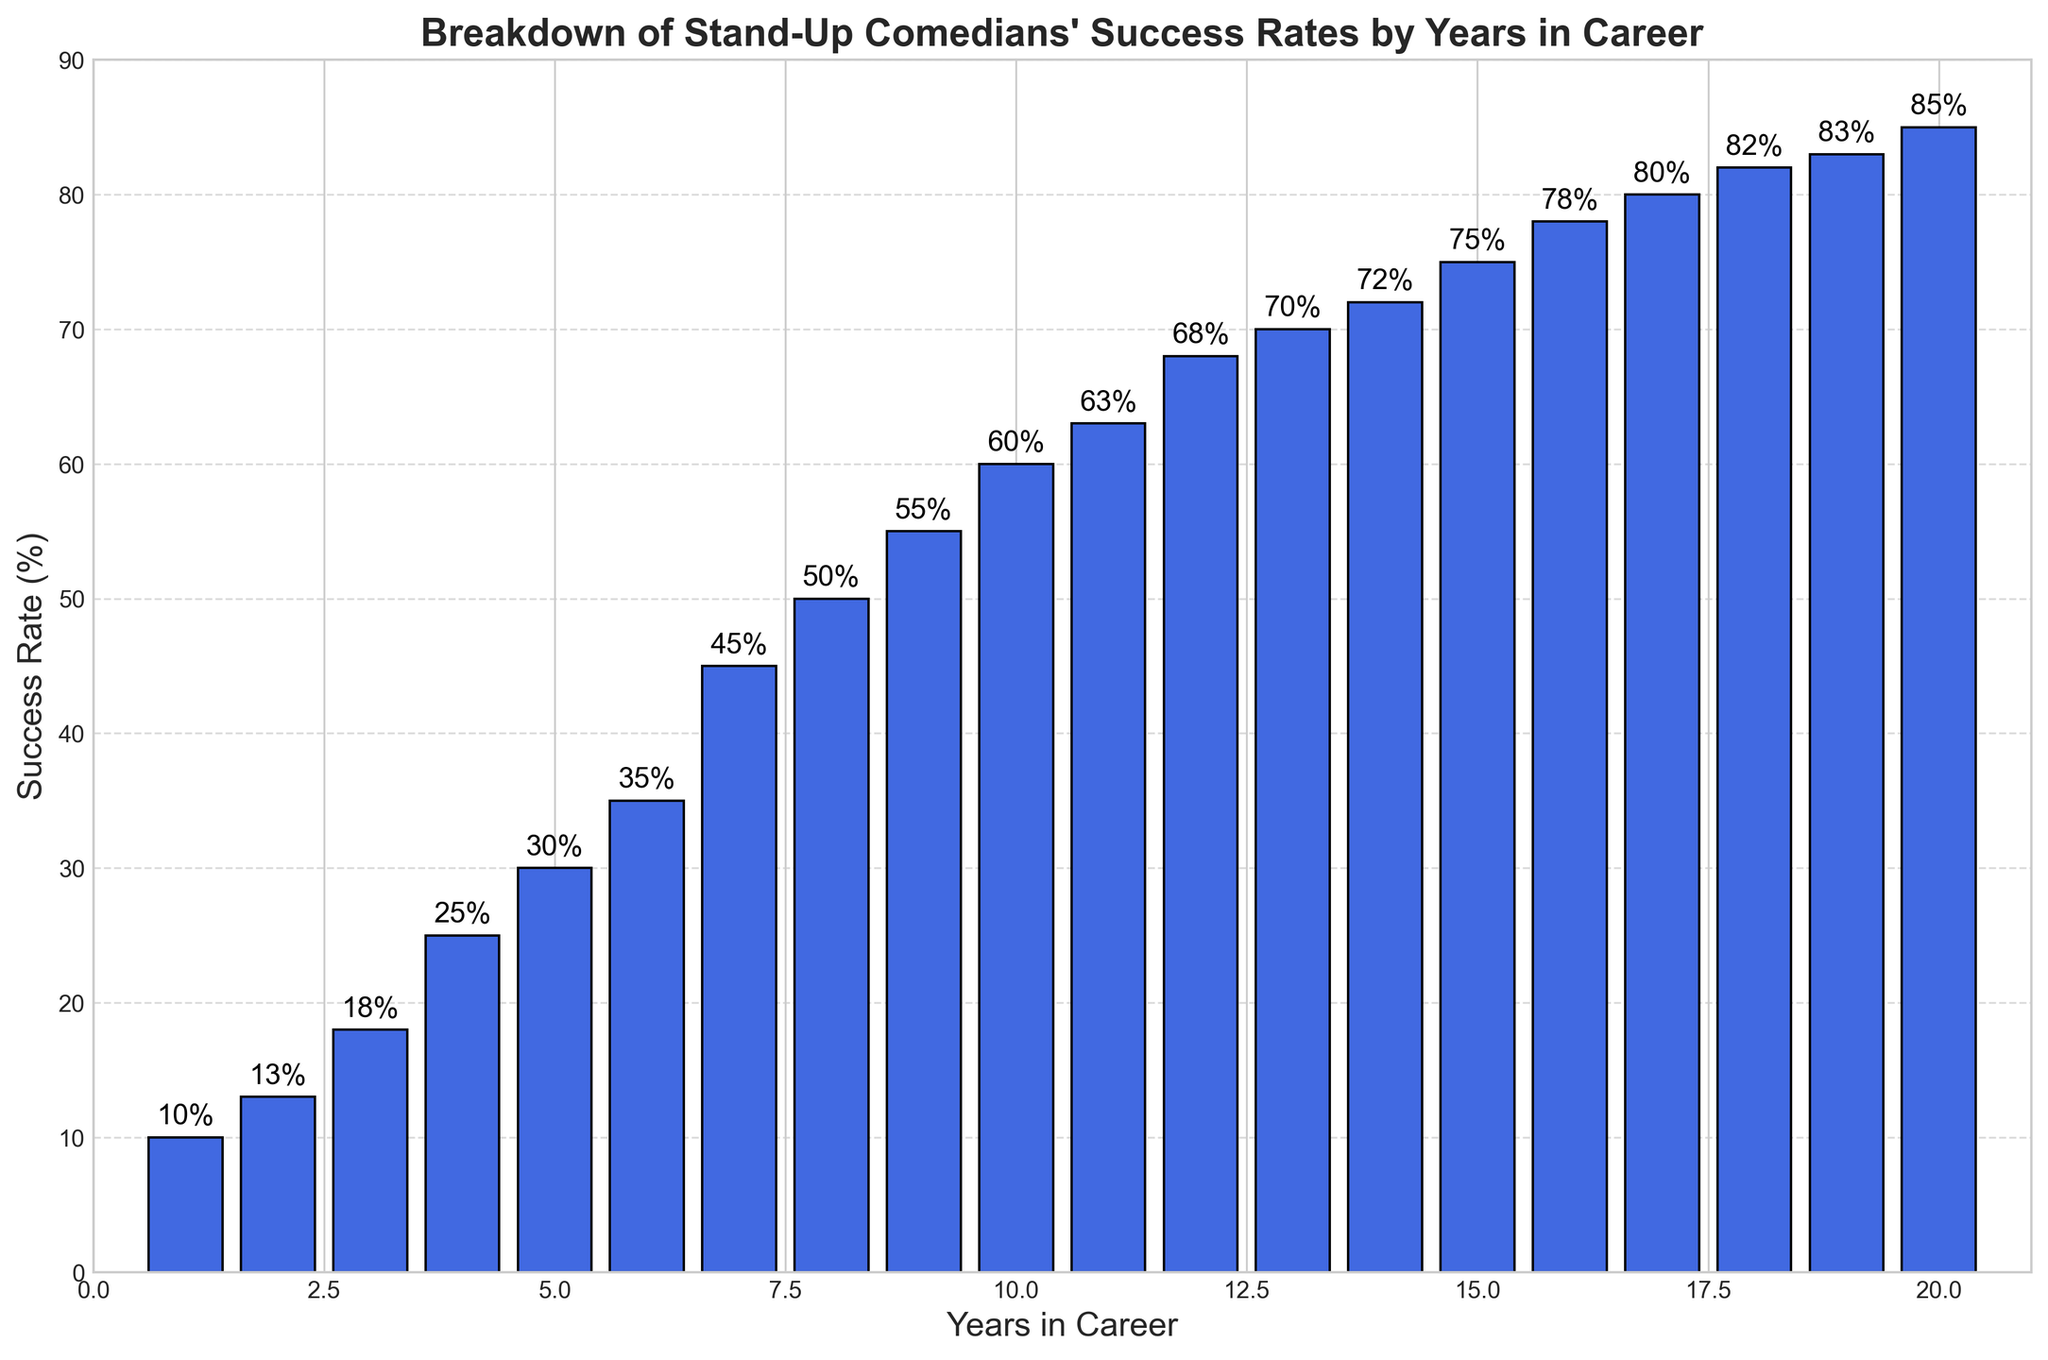what's the average success rate for comedians with less than 5 years in their career? There are 4 data points for comedians with less than 5 years in their career: 10, 13, 18, and 25. Add these values together to get 66 and then divide by 4 to find the average: 66 / 4 = 16.5
Answer: 16.5 Which year marks the first time comedians achieve a success rate of at least 50%? Look for the bar where the success rate first reaches at least 50%. This happens at the 8-year mark where the success rate is 50%.
Answer: 8 What's the difference in success rate between comedians with 10 years and 5 years in their career? The success rate for comedians at 10 years is 60%, and at 5 years it is 30%. Subtract the two values: 60 - 30 = 30% difference.
Answer: 30 How many years into a career does it take for a comedian to surpass a 75% success rate? Look for the first bar where the success rate exceeds 75%. This happens at the 15-year mark with a success rate of 75%.
Answer: 15 By what percent does the success rate increase from year 17 to year 18? The success rate at year 17 is 80% and at year 18 is 82%. Subtract the success rates and then divide by the year 17 rate to get the percentage increase: (82 - 80) / 80 = 0.025 or 2.5%.
Answer: 2.5 what's the highest success rate achieved within the first 10 years of a stand-up comedian's career? The bar representing the 10th year shows a success rate of 60%, which is the highest success rate within the first 10 years.
Answer: 60 